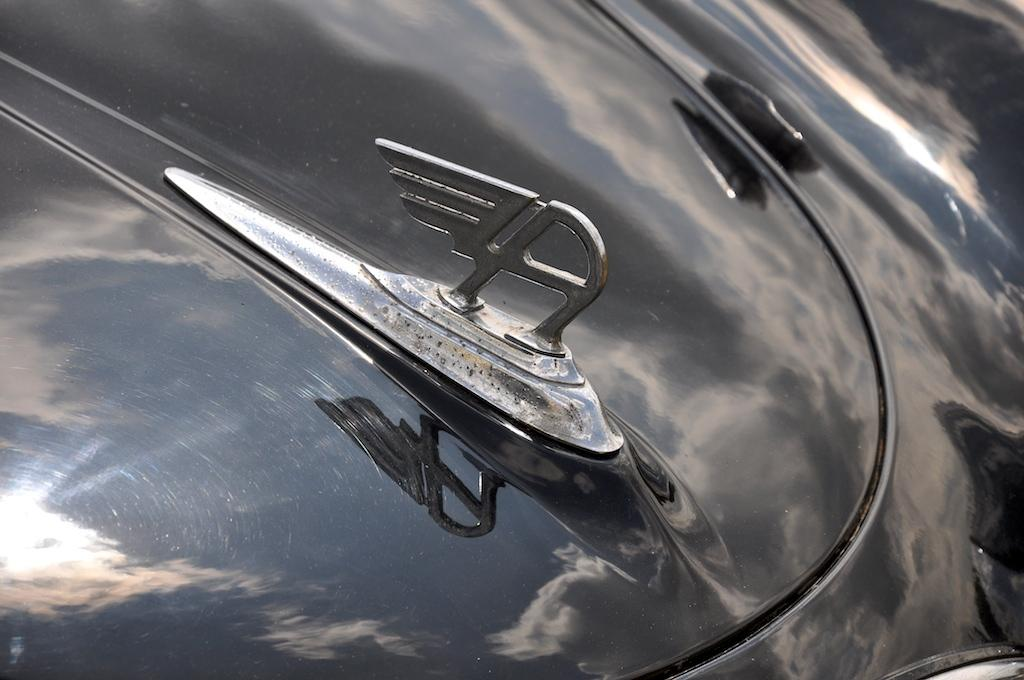What is the main subject of the image? The main subject of the image is a vehicle emblem. Can you describe the details of the emblem? Unfortunately, the image is a zoomed-in picture, so it's difficult to see the entire emblem or its details. How many crows are involved in the fight depicted in the image? There is no fight or crows present in the image; it is a zoomed-in picture of a vehicle emblem. 